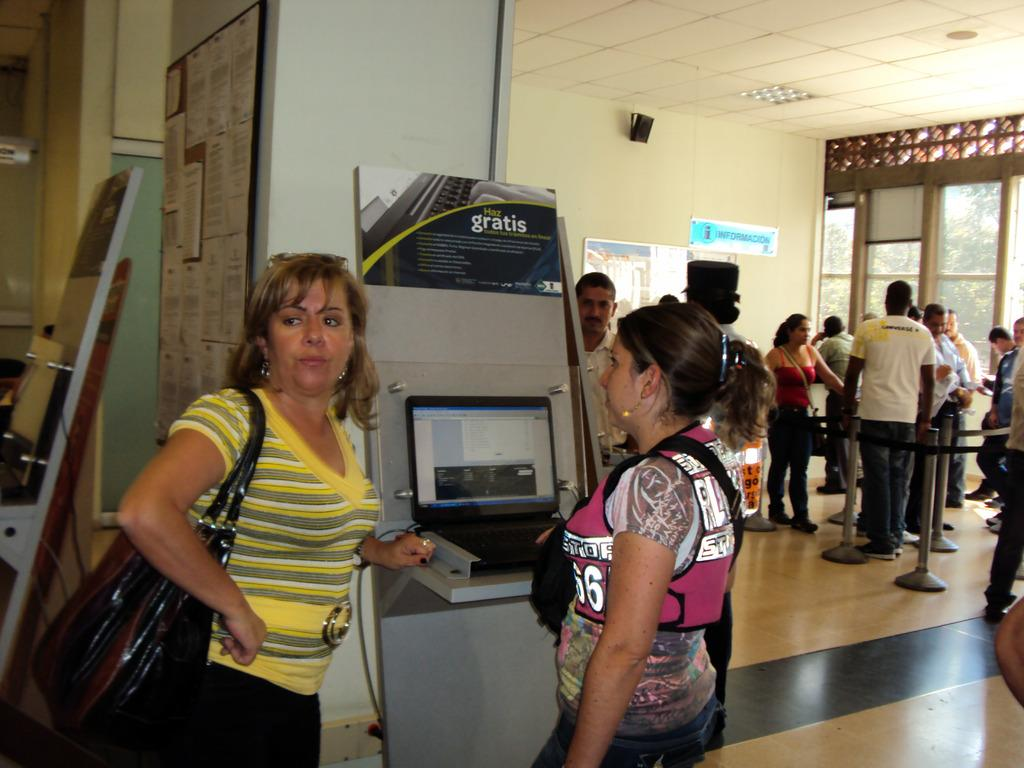<image>
Summarize the visual content of the image. Two women stand in front of a counter above which is a sign that says Gratis. 